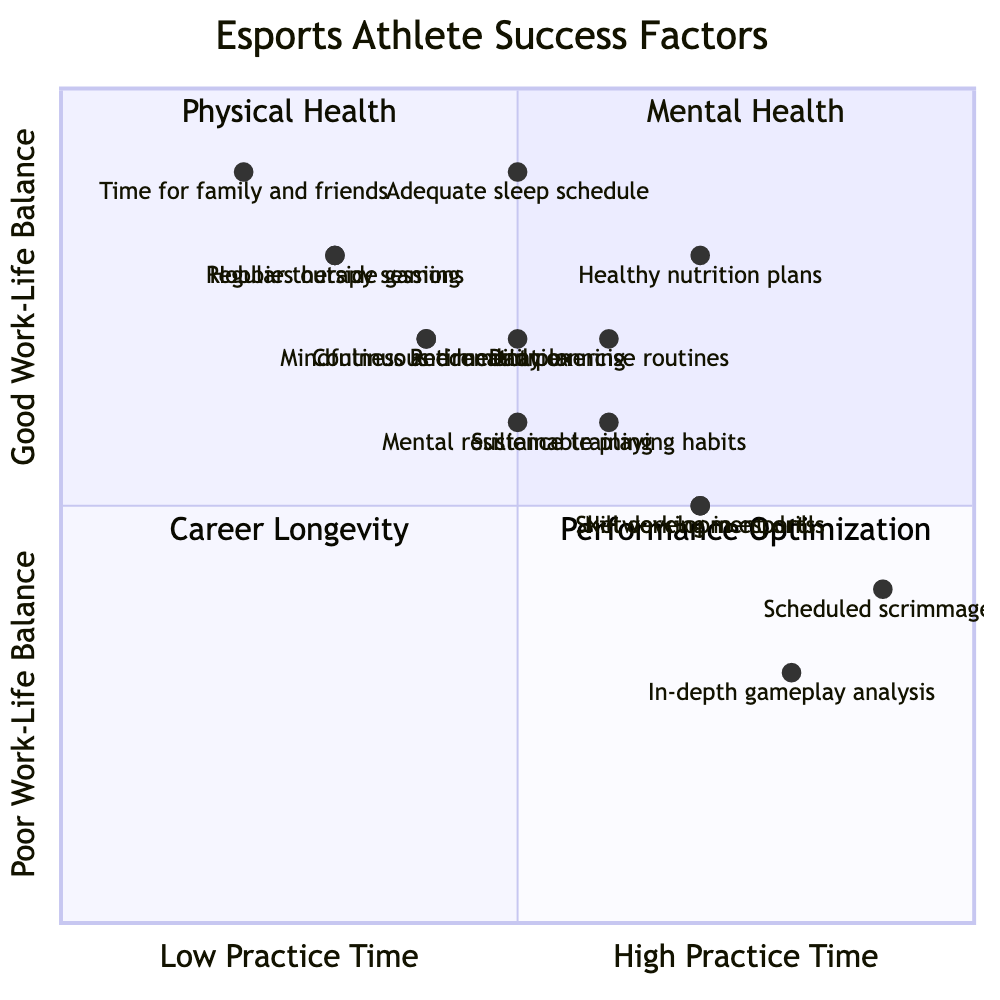What is the position of "Healthy nutrition plans" in the diagram? "Healthy nutrition plans" is located in the "Personal Well-being: Physical Health" quadrant, with coordinates [0.7, 0.8] indicating a relatively high practice time and a good work-life balance.
Answer: [0.7, 0.8] How many items are in the "Work-Life Balance" quadrant? There are three items listed in the "Work-Life Balance" quadrant: "Time management for family and friends," "Hobbies outside of gaming," and "Continuous education and personal growth."
Answer: 3 What is the highest position for "Mental Health" items with respect to work-life balance? The highest position for "Mental Health" items is occupied by "Regular therapy sessions" at [0.3, 0.8], indicating a fairly good work-life balance despite lower practice time.
Answer: [0.3, 0.8] Which item is associated with the highest practice time alongside the lowest work-life balance? "Scheduled scrimmages" at [0.9, 0.4] is associated with the highest practice time while also having a low work-life balance.
Answer: Scheduled scrimmages How does "Networking within the esports community" relate to work-life balance compared to "In-depth analysis of gameplay"? "Networking within the esports community" has coordinates [0.7, 0.5], indicating a moderate work-life balance, whereas "In-depth analysis of gameplay" at [0.8, 0.3] has a lower position, suggesting poorer work-life balance.
Answer: Lower work-life balance Which item demonstrates a balance between "Career Longevity" and "Practice Time"? "Sustainable playing habits" at [0.6, 0.6] represents a balance between "Career Longevity" and "Practice Time," placing it in a favorable middle ground between both factors.
Answer: Sustainable playing habits What factor has a value below 0.5 for work-life balance? "Skill development drills" has coordinates [0.7, 0.5], and any value lower than 0.5 would be considered below that threshold; none in the provided items fall below 0.5 in work-life balance.
Answer: None Which quadrant contains items that are focused on enhancing physical well-being? The "Personal Well-being: Physical Health" quadrant specifically contains items such as "Daily exercise routines," "Healthy nutrition plans," and "Adequate sleep schedule" aimed at enhancing physical well-being.
Answer: Personal Well-being: Physical Health 